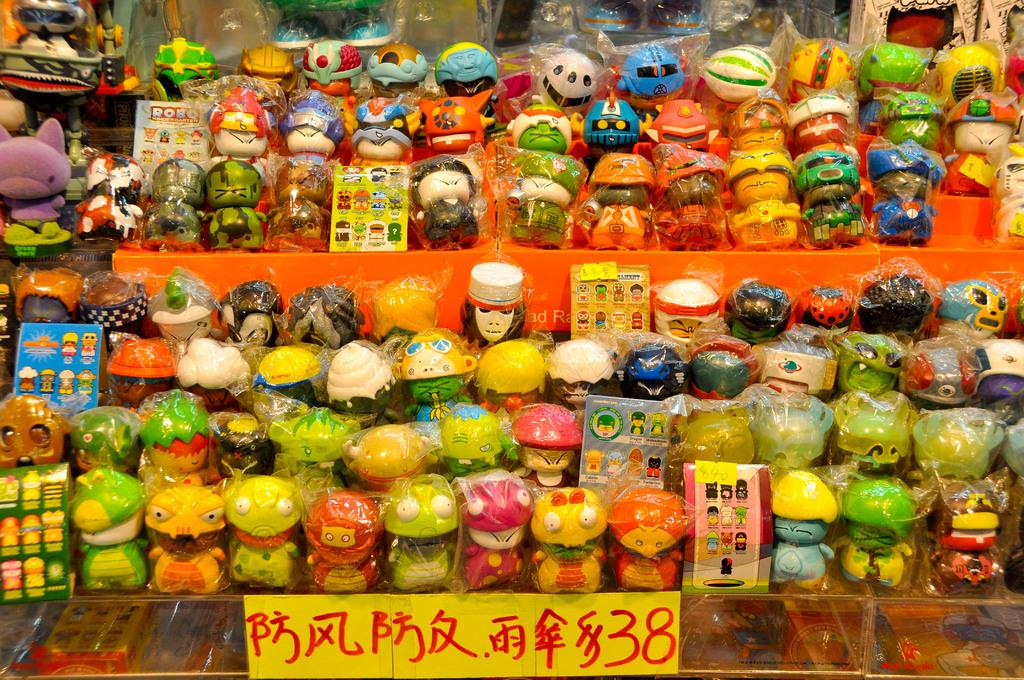<image>
Present a compact description of the photo's key features. A display of items for sale, that are selling for a denomination of 38. 